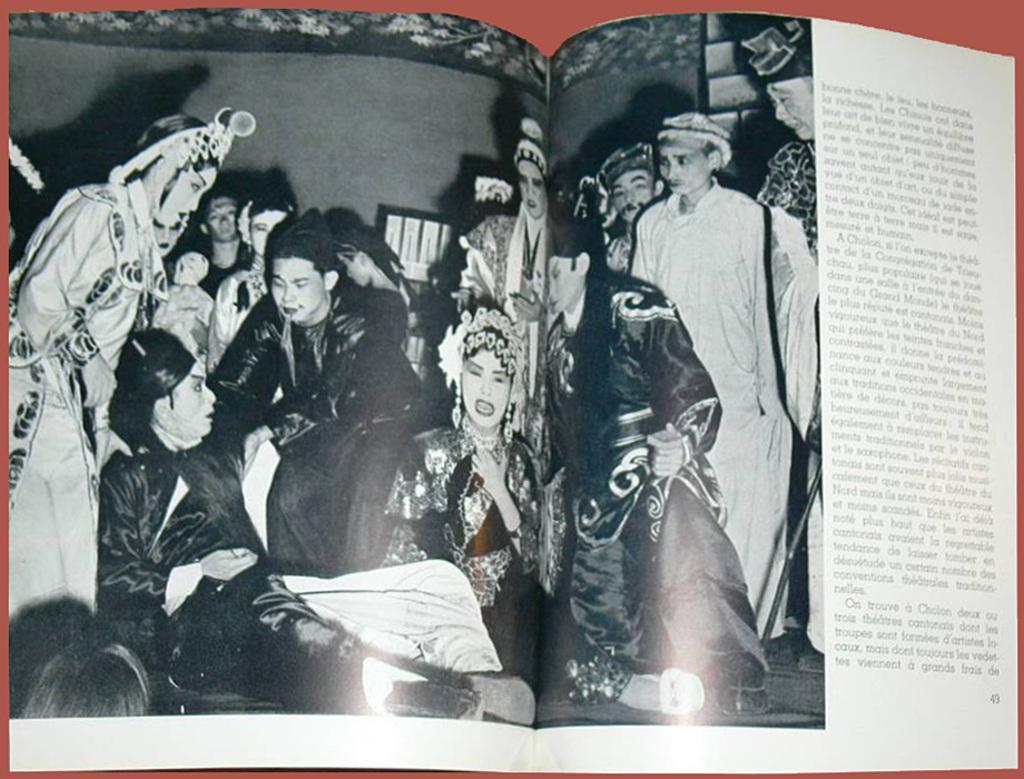In one or two sentences, can you explain what this image depicts? In the center of the image we can see book placed on the table. 